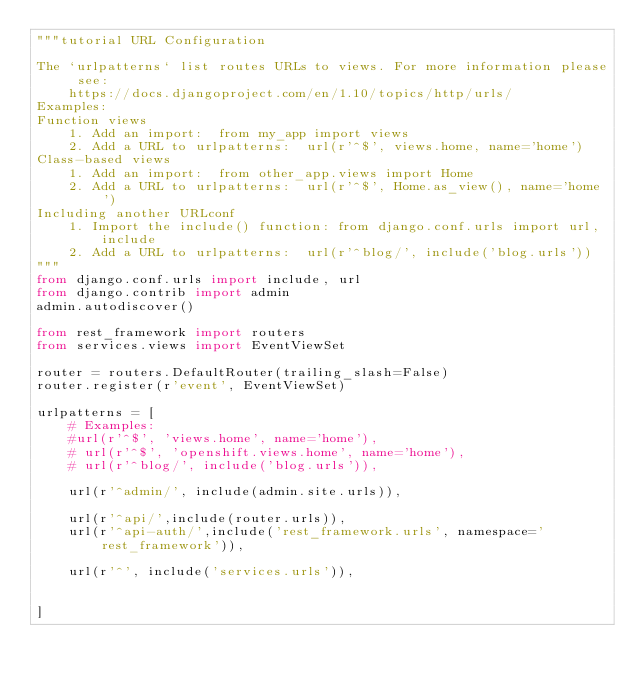<code> <loc_0><loc_0><loc_500><loc_500><_Python_>"""tutorial URL Configuration

The `urlpatterns` list routes URLs to views. For more information please see:
    https://docs.djangoproject.com/en/1.10/topics/http/urls/
Examples:
Function views
    1. Add an import:  from my_app import views
    2. Add a URL to urlpatterns:  url(r'^$', views.home, name='home')
Class-based views
    1. Add an import:  from other_app.views import Home
    2. Add a URL to urlpatterns:  url(r'^$', Home.as_view(), name='home')
Including another URLconf
    1. Import the include() function: from django.conf.urls import url, include
    2. Add a URL to urlpatterns:  url(r'^blog/', include('blog.urls'))
"""
from django.conf.urls import include, url
from django.contrib import admin
admin.autodiscover()

from rest_framework import routers
from services.views import EventViewSet

router = routers.DefaultRouter(trailing_slash=False)
router.register(r'event', EventViewSet)

urlpatterns = [
	# Examples:
	#url(r'^$', 'views.home', name='home'),
	# url(r'^$', 'openshift.views.home', name='home'),
	# url(r'^blog/', include('blog.urls')),

	url(r'^admin/', include(admin.site.urls)),

	url(r'^api/',include(router.urls)),
	url(r'^api-auth/',include('rest_framework.urls', namespace='rest_framework')),

    url(r'^', include('services.urls')),

	
]</code> 